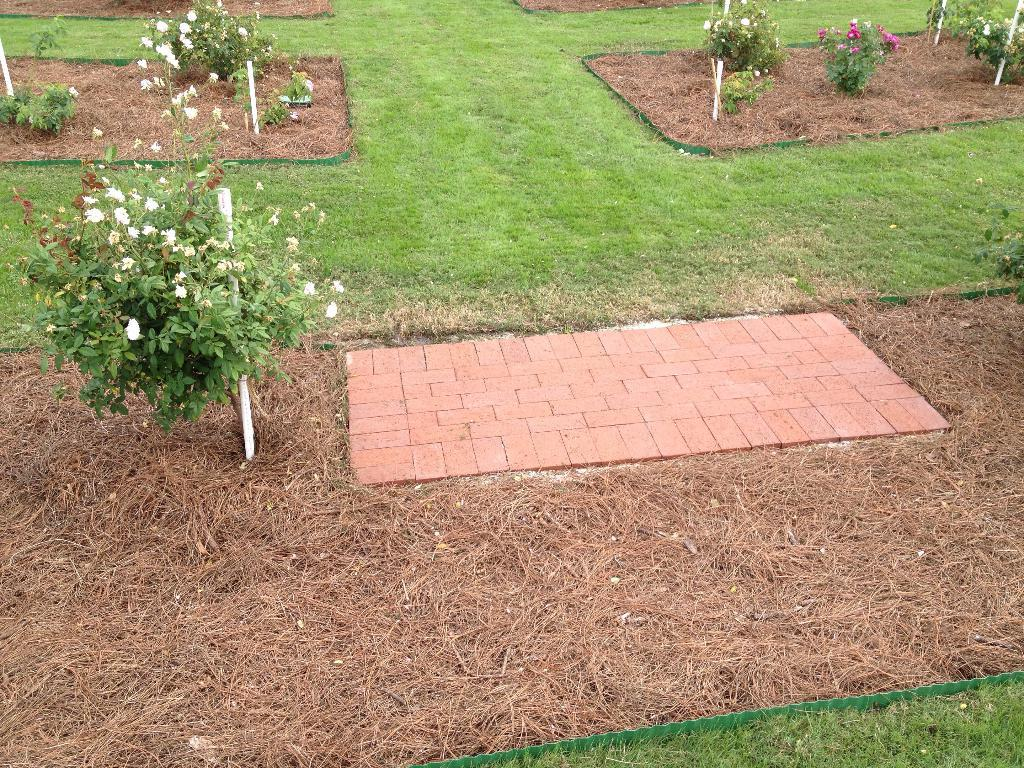What type of vegetation can be seen in the image? There are plants and flowers in the image. What is the ground covered with in the image? There is grass in the image. What song is being sung by the company in the image? There is no song or company present in the image; it features plants, flowers, and grass. 